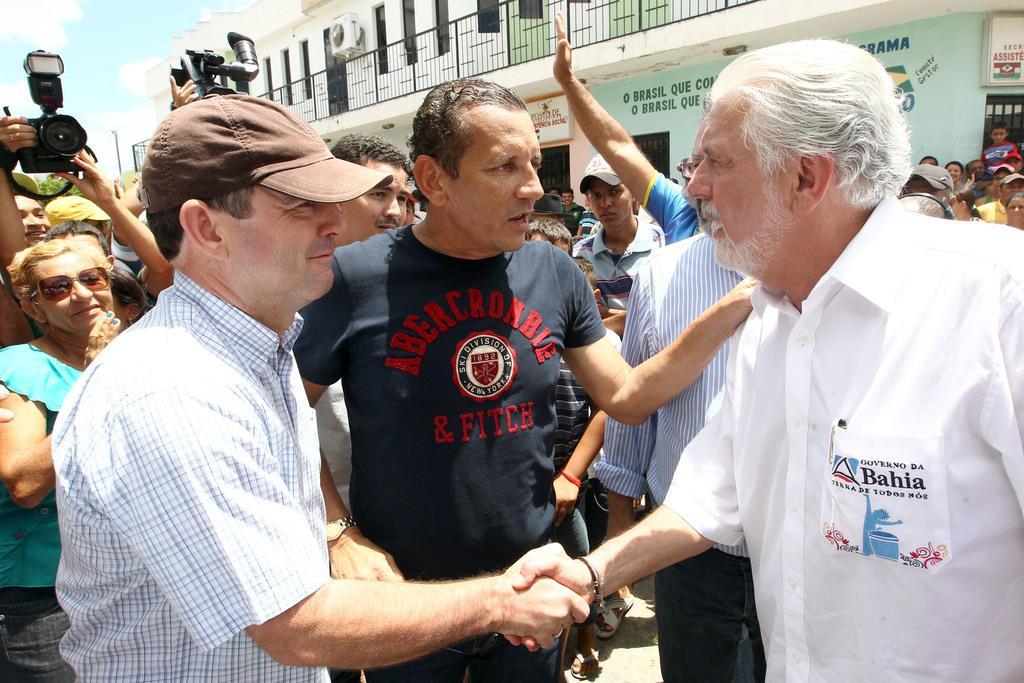In one or two sentences, can you explain what this image depicts? There is a crowd. Some are wearing caps. A person on the left is wearing goggles. And some are holding cameras. In the back there is a building with windows, railing and AC. On the building something is written. 